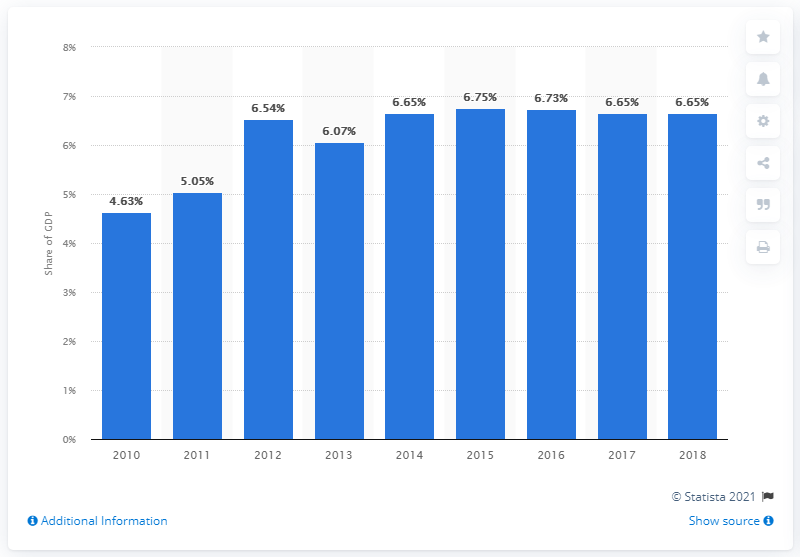Identify some key points in this picture. In 2015, Paraguay experienced the highest healthcare expenditure. 